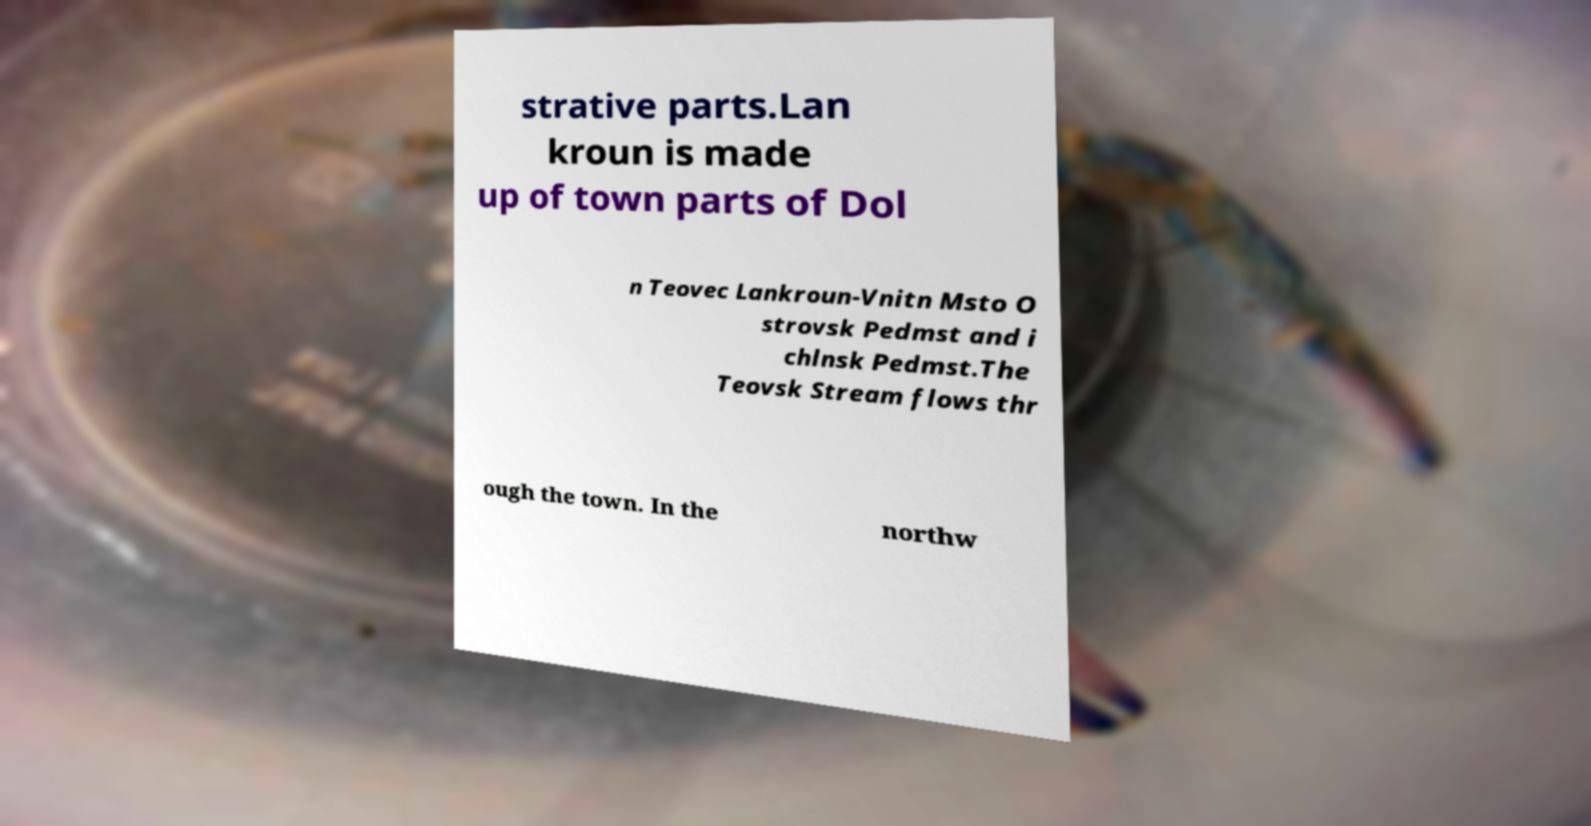I need the written content from this picture converted into text. Can you do that? strative parts.Lan kroun is made up of town parts of Dol n Teovec Lankroun-Vnitn Msto O strovsk Pedmst and i chlnsk Pedmst.The Teovsk Stream flows thr ough the town. In the northw 